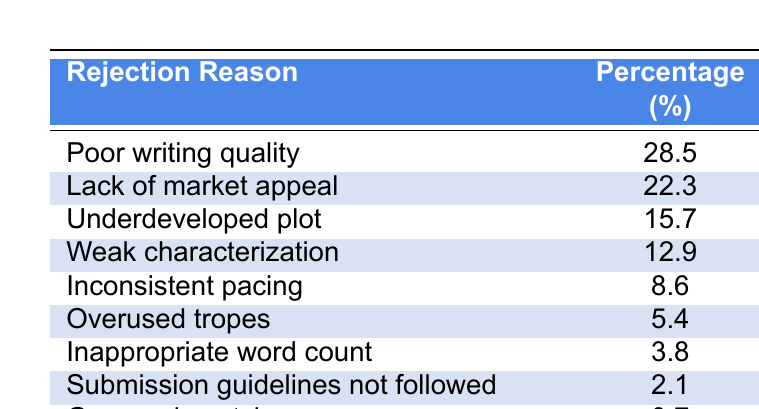What is the most common reason for manuscript rejection? The table shows that "Poor writing quality" has the highest percentage at 28.5%, which indicates it is the most common reason for rejection.
Answer: Poor writing quality What percentage of rejections is due to a lack of market appeal? According to the table, "Lack of market appeal" accounts for 22.3% of manuscript rejections.
Answer: 22.3% Are there any rejection reasons that are over 20%? The table indicates that both "Poor writing quality" and "Lack of market appeal" are over 20%, each being 28.5% and 22.3%, respectively.
Answer: Yes What is the sum of the percentages for the top three rejection reasons? The top three reasons and their percentages are: Poor writing quality (28.5), Lack of market appeal (22.3), and Underdeveloped plot (15.7). Summing these gives: 28.5 + 22.3 + 15.7 = 66.5%.
Answer: 66.5% What percentage of rejections is due to reasons that are considered less common (below 5%)? The table shows the only reason below 5% is "Genre mismatch" at 0.7%. Since this is the only relevant data point, the percentage of rejections due to less common reasons is 0.7%.
Answer: 0.7% Is "Weak characterization" a more common rejection reason than "Inappropriate word count"? "Weak characterization" has a percentage of 12.9%, while "Inappropriate word count" has only 3.8%. Since 12.9% is greater than 3.8%, it confirms that "Weak characterization" is indeed more common.
Answer: Yes What is the percentage difference between the most common and least common rejection reasons? The most common rejection reason, "Poor writing quality," is at 28.5%, and the least common reason, "Genre mismatch," is at 0.7%. The difference is calculated as 28.5 - 0.7 = 27.8%.
Answer: 27.8% If a manuscript is rejected for "Submission guidelines not followed," how does this compare to "Overused tropes"? "Submission guidelines not followed" has a percentage of 2.1%, while "Overused tropes" has a higher percentage of 5.4%. Thus, "Overused tropes" is the more common reason in this instance.
Answer: Overused tropes is more common What percentage of rejections is accounted for by reasons related to writing and development (poor writing quality, underdeveloped plot, weak characterization, inconsistent pacing)? Summing the relevant percentages: Poor writing quality (28.5) + Underdeveloped plot (15.7) + Weak characterization (12.9) + Inconsistent pacing (8.6) gives a total of 65.7%.
Answer: 65.7% 